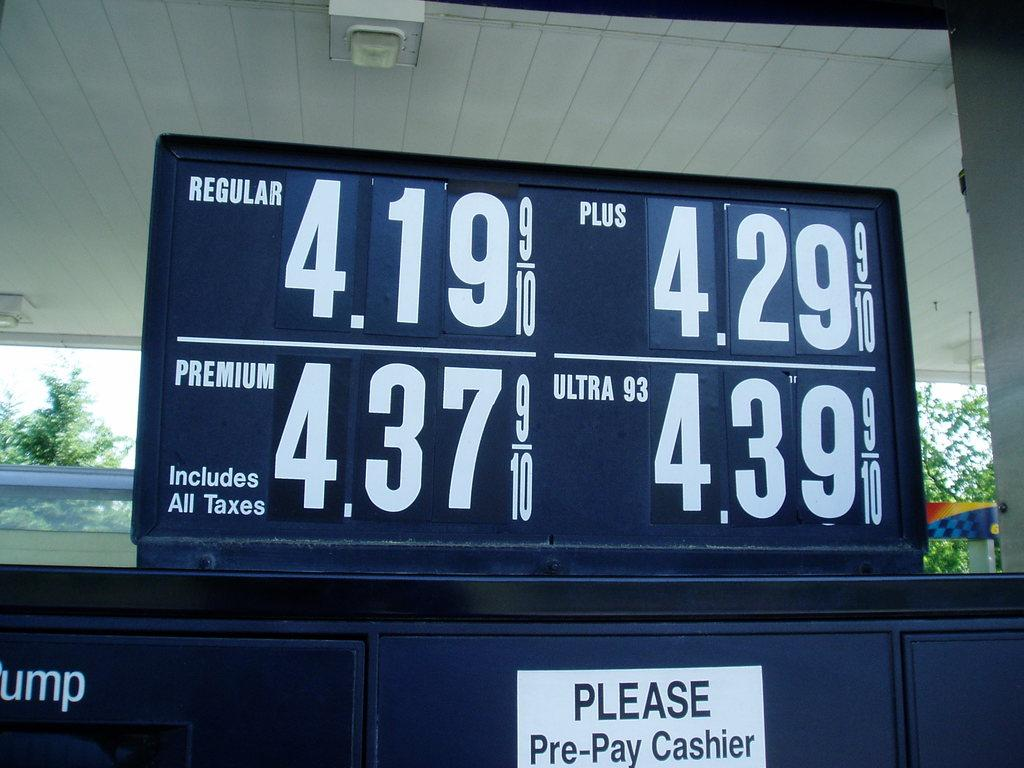<image>
Give a short and clear explanation of the subsequent image. Prices on a gas pump and a sign that says to pre-pay. 